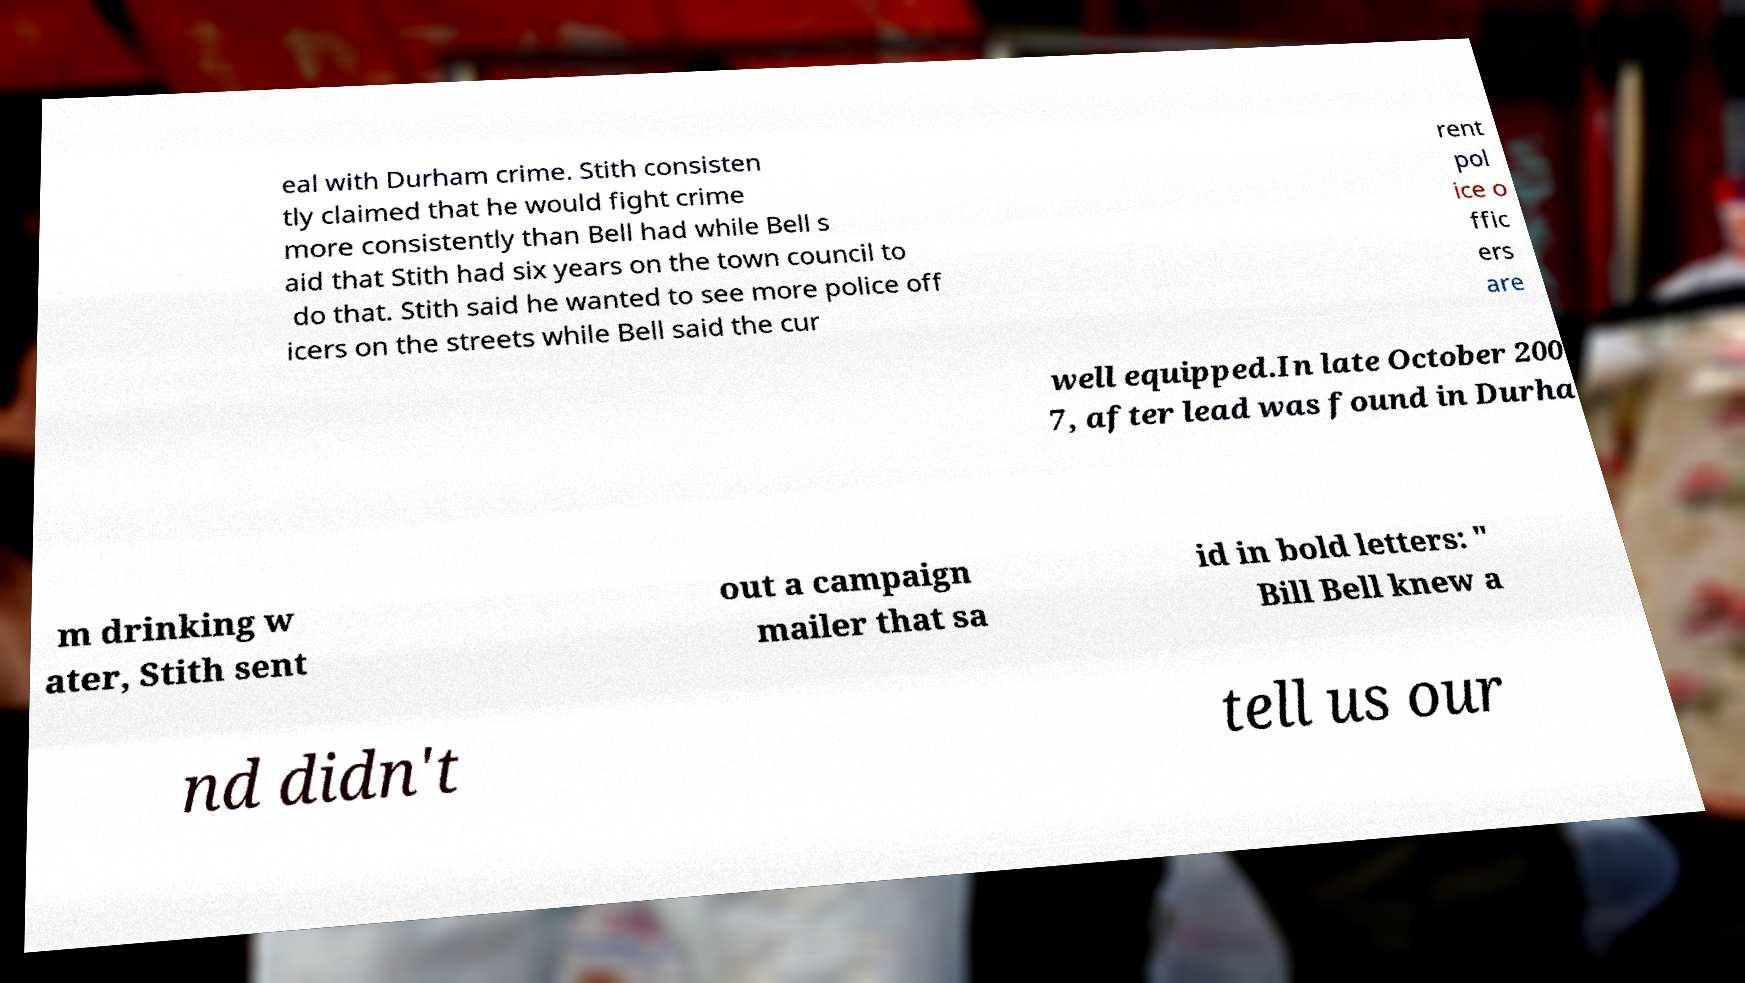Could you extract and type out the text from this image? eal with Durham crime. Stith consisten tly claimed that he would fight crime more consistently than Bell had while Bell s aid that Stith had six years on the town council to do that. Stith said he wanted to see more police off icers on the streets while Bell said the cur rent pol ice o ffic ers are well equipped.In late October 200 7, after lead was found in Durha m drinking w ater, Stith sent out a campaign mailer that sa id in bold letters: " Bill Bell knew a nd didn't tell us our 